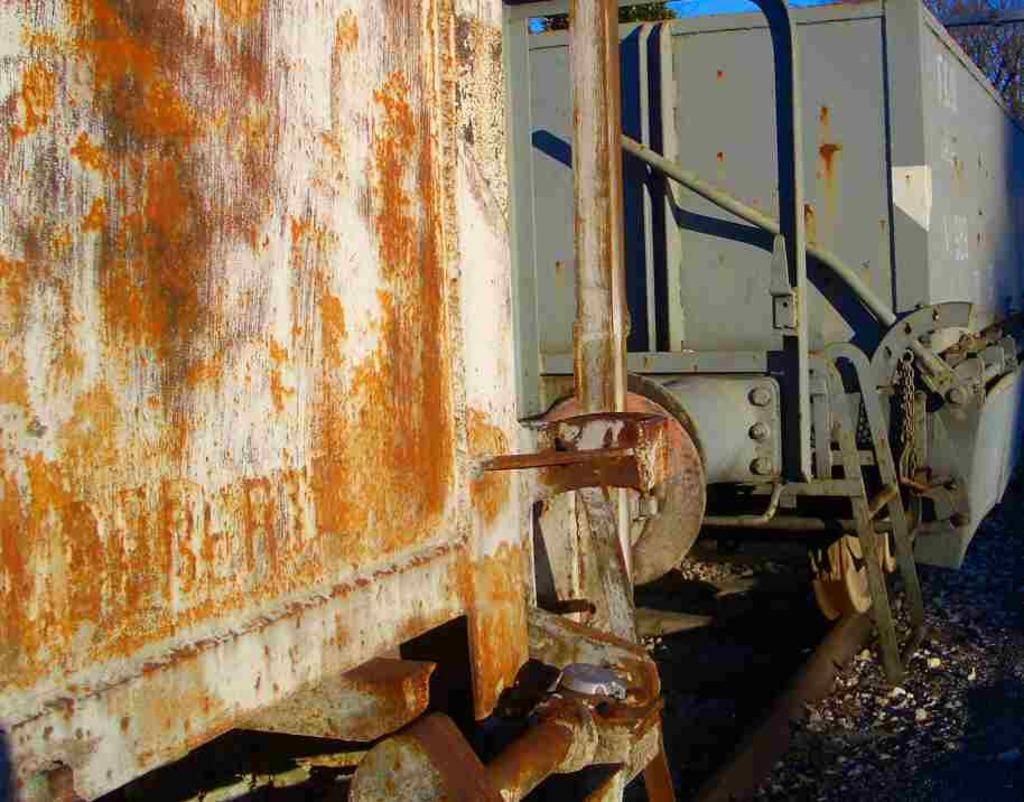What is the main subject of the image? The main subject of the image is the goods carriers of a train. Where are the goods carriers located in the image? The goods carriers are in the foreground of the image. What can be observed about the positioning of the goods carriers? The goods carriers are on a track. What type of cloth is draped over the goods carriers in the image? There is no cloth draped over the goods carriers in the image. What kind of drug is being transported in the goods carriers in the image? There is no indication of any drug being transported in the image; it features goods carriers of a train on a track. 